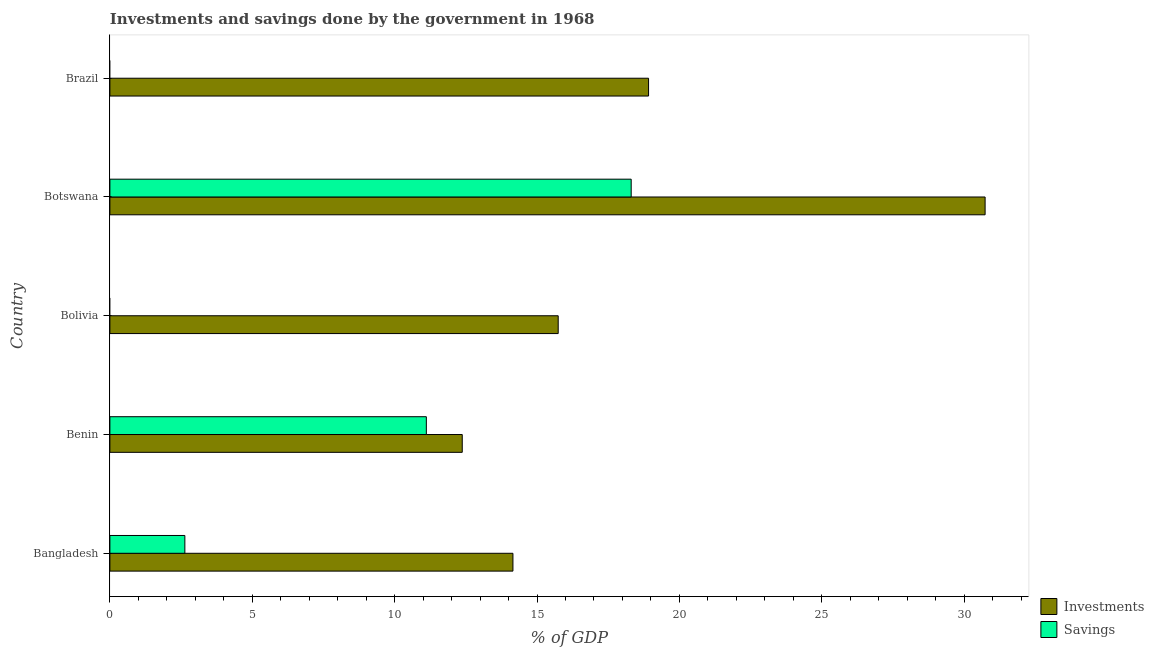How many different coloured bars are there?
Your answer should be compact. 2. Are the number of bars per tick equal to the number of legend labels?
Give a very brief answer. No. How many bars are there on the 2nd tick from the top?
Offer a terse response. 2. What is the label of the 2nd group of bars from the top?
Give a very brief answer. Botswana. In how many cases, is the number of bars for a given country not equal to the number of legend labels?
Your response must be concise. 2. What is the investments of government in Bolivia?
Make the answer very short. 15.74. Across all countries, what is the maximum investments of government?
Provide a succinct answer. 30.74. Across all countries, what is the minimum investments of government?
Ensure brevity in your answer.  12.37. In which country was the investments of government maximum?
Ensure brevity in your answer.  Botswana. What is the total investments of government in the graph?
Your answer should be compact. 91.93. What is the difference between the investments of government in Bangladesh and that in Benin?
Ensure brevity in your answer.  1.78. What is the difference between the investments of government in Botswana and the savings of government in Bolivia?
Keep it short and to the point. 30.74. What is the average investments of government per country?
Your response must be concise. 18.39. What is the difference between the savings of government and investments of government in Botswana?
Make the answer very short. -12.43. What is the ratio of the savings of government in Bangladesh to that in Botswana?
Provide a short and direct response. 0.14. Is the investments of government in Bangladesh less than that in Benin?
Provide a succinct answer. No. Is the difference between the savings of government in Bangladesh and Benin greater than the difference between the investments of government in Bangladesh and Benin?
Give a very brief answer. No. What is the difference between the highest and the second highest investments of government?
Your response must be concise. 11.82. What is the difference between the highest and the lowest savings of government?
Offer a terse response. 18.31. In how many countries, is the investments of government greater than the average investments of government taken over all countries?
Your answer should be very brief. 2. How many countries are there in the graph?
Offer a very short reply. 5. What is the difference between two consecutive major ticks on the X-axis?
Keep it short and to the point. 5. Are the values on the major ticks of X-axis written in scientific E-notation?
Give a very brief answer. No. Does the graph contain any zero values?
Provide a succinct answer. Yes. Where does the legend appear in the graph?
Ensure brevity in your answer.  Bottom right. What is the title of the graph?
Provide a succinct answer. Investments and savings done by the government in 1968. What is the label or title of the X-axis?
Make the answer very short. % of GDP. What is the label or title of the Y-axis?
Offer a terse response. Country. What is the % of GDP in Investments in Bangladesh?
Ensure brevity in your answer.  14.15. What is the % of GDP in Savings in Bangladesh?
Your answer should be compact. 2.63. What is the % of GDP in Investments in Benin?
Provide a succinct answer. 12.37. What is the % of GDP of Savings in Benin?
Keep it short and to the point. 11.11. What is the % of GDP in Investments in Bolivia?
Your answer should be compact. 15.74. What is the % of GDP of Savings in Bolivia?
Ensure brevity in your answer.  0. What is the % of GDP of Investments in Botswana?
Provide a succinct answer. 30.74. What is the % of GDP in Savings in Botswana?
Offer a very short reply. 18.31. What is the % of GDP in Investments in Brazil?
Keep it short and to the point. 18.92. What is the % of GDP in Savings in Brazil?
Provide a short and direct response. 0. Across all countries, what is the maximum % of GDP in Investments?
Provide a short and direct response. 30.74. Across all countries, what is the maximum % of GDP of Savings?
Provide a short and direct response. 18.31. Across all countries, what is the minimum % of GDP in Investments?
Your response must be concise. 12.37. What is the total % of GDP of Investments in the graph?
Ensure brevity in your answer.  91.93. What is the total % of GDP of Savings in the graph?
Your response must be concise. 32.05. What is the difference between the % of GDP in Investments in Bangladesh and that in Benin?
Keep it short and to the point. 1.78. What is the difference between the % of GDP in Savings in Bangladesh and that in Benin?
Your answer should be very brief. -8.48. What is the difference between the % of GDP in Investments in Bangladesh and that in Bolivia?
Give a very brief answer. -1.59. What is the difference between the % of GDP in Investments in Bangladesh and that in Botswana?
Your response must be concise. -16.58. What is the difference between the % of GDP of Savings in Bangladesh and that in Botswana?
Provide a succinct answer. -15.68. What is the difference between the % of GDP in Investments in Bangladesh and that in Brazil?
Offer a terse response. -4.76. What is the difference between the % of GDP of Investments in Benin and that in Bolivia?
Keep it short and to the point. -3.37. What is the difference between the % of GDP of Investments in Benin and that in Botswana?
Your answer should be compact. -18.36. What is the difference between the % of GDP of Savings in Benin and that in Botswana?
Ensure brevity in your answer.  -7.19. What is the difference between the % of GDP in Investments in Benin and that in Brazil?
Keep it short and to the point. -6.54. What is the difference between the % of GDP of Investments in Bolivia and that in Botswana?
Provide a short and direct response. -14.99. What is the difference between the % of GDP in Investments in Bolivia and that in Brazil?
Your answer should be very brief. -3.17. What is the difference between the % of GDP of Investments in Botswana and that in Brazil?
Your response must be concise. 11.82. What is the difference between the % of GDP in Investments in Bangladesh and the % of GDP in Savings in Benin?
Provide a short and direct response. 3.04. What is the difference between the % of GDP in Investments in Bangladesh and the % of GDP in Savings in Botswana?
Your answer should be very brief. -4.15. What is the difference between the % of GDP in Investments in Benin and the % of GDP in Savings in Botswana?
Your response must be concise. -5.93. What is the difference between the % of GDP in Investments in Bolivia and the % of GDP in Savings in Botswana?
Ensure brevity in your answer.  -2.56. What is the average % of GDP in Investments per country?
Offer a terse response. 18.39. What is the average % of GDP of Savings per country?
Your answer should be very brief. 6.41. What is the difference between the % of GDP in Investments and % of GDP in Savings in Bangladesh?
Offer a terse response. 11.52. What is the difference between the % of GDP in Investments and % of GDP in Savings in Benin?
Provide a succinct answer. 1.26. What is the difference between the % of GDP in Investments and % of GDP in Savings in Botswana?
Your answer should be very brief. 12.43. What is the ratio of the % of GDP in Investments in Bangladesh to that in Benin?
Ensure brevity in your answer.  1.14. What is the ratio of the % of GDP of Savings in Bangladesh to that in Benin?
Make the answer very short. 0.24. What is the ratio of the % of GDP of Investments in Bangladesh to that in Bolivia?
Your response must be concise. 0.9. What is the ratio of the % of GDP of Investments in Bangladesh to that in Botswana?
Keep it short and to the point. 0.46. What is the ratio of the % of GDP in Savings in Bangladesh to that in Botswana?
Your answer should be compact. 0.14. What is the ratio of the % of GDP in Investments in Bangladesh to that in Brazil?
Make the answer very short. 0.75. What is the ratio of the % of GDP of Investments in Benin to that in Bolivia?
Offer a terse response. 0.79. What is the ratio of the % of GDP of Investments in Benin to that in Botswana?
Your answer should be compact. 0.4. What is the ratio of the % of GDP in Savings in Benin to that in Botswana?
Make the answer very short. 0.61. What is the ratio of the % of GDP in Investments in Benin to that in Brazil?
Give a very brief answer. 0.65. What is the ratio of the % of GDP of Investments in Bolivia to that in Botswana?
Offer a terse response. 0.51. What is the ratio of the % of GDP in Investments in Bolivia to that in Brazil?
Give a very brief answer. 0.83. What is the ratio of the % of GDP of Investments in Botswana to that in Brazil?
Keep it short and to the point. 1.62. What is the difference between the highest and the second highest % of GDP of Investments?
Offer a very short reply. 11.82. What is the difference between the highest and the second highest % of GDP of Savings?
Ensure brevity in your answer.  7.19. What is the difference between the highest and the lowest % of GDP in Investments?
Your response must be concise. 18.36. What is the difference between the highest and the lowest % of GDP in Savings?
Offer a very short reply. 18.31. 